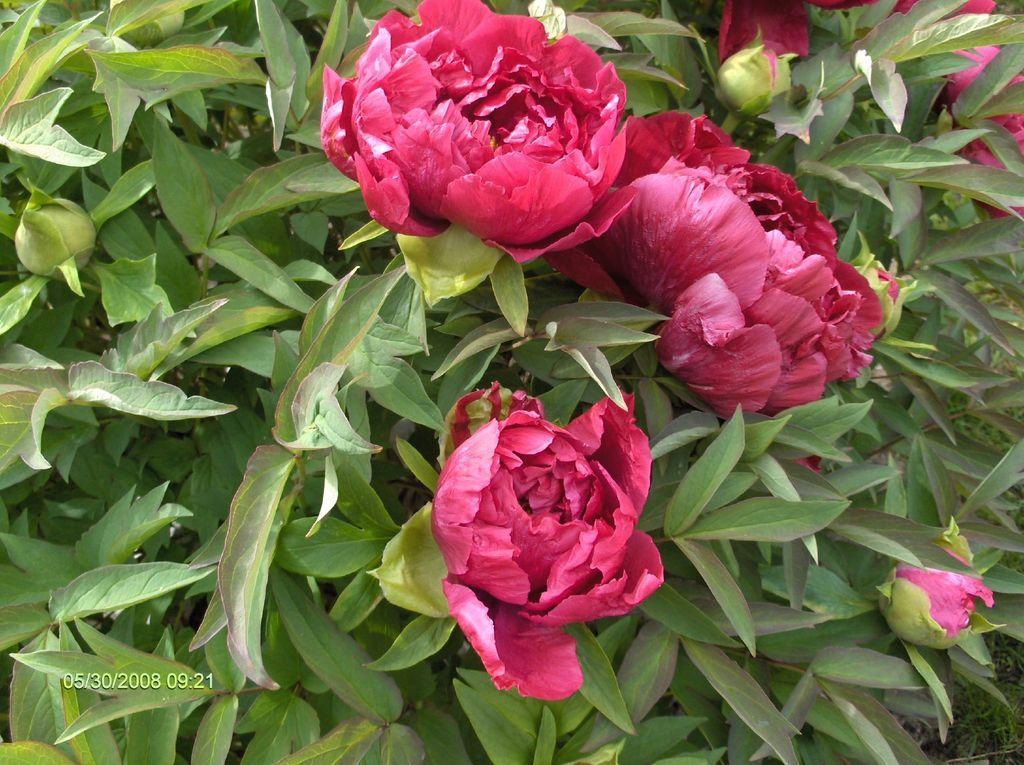Can you describe this image briefly? In this image we can see red color flowers and green color leaves and buds. 